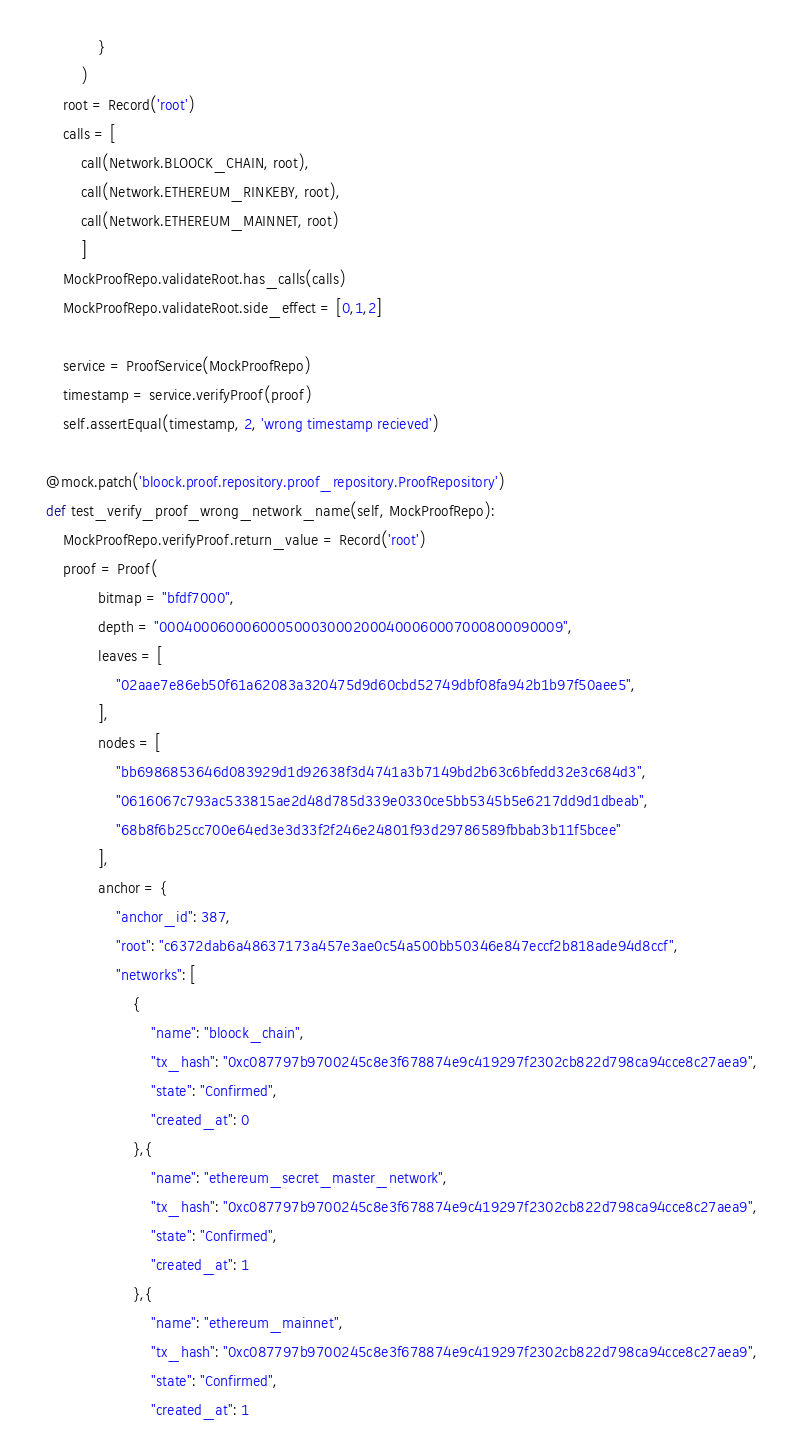Convert code to text. <code><loc_0><loc_0><loc_500><loc_500><_Python_>                }
            )
        root = Record('root')
        calls = [
            call(Network.BLOOCK_CHAIN, root),
            call(Network.ETHEREUM_RINKEBY, root),
            call(Network.ETHEREUM_MAINNET, root)
            ]
        MockProofRepo.validateRoot.has_calls(calls)
        MockProofRepo.validateRoot.side_effect = [0,1,2]

        service = ProofService(MockProofRepo)
        timestamp = service.verifyProof(proof)
        self.assertEqual(timestamp, 2, 'wrong timestamp recieved')

    @mock.patch('bloock.proof.repository.proof_repository.ProofRepository')
    def test_verify_proof_wrong_network_name(self, MockProofRepo):
        MockProofRepo.verifyProof.return_value = Record('root')
        proof = Proof(
                bitmap = "bfdf7000",
                depth = "000400060006000500030002000400060007000800090009",
                leaves = [
                    "02aae7e86eb50f61a62083a320475d9d60cbd52749dbf08fa942b1b97f50aee5",
                ],
                nodes = [
                    "bb6986853646d083929d1d92638f3d4741a3b7149bd2b63c6bfedd32e3c684d3",
                    "0616067c793ac533815ae2d48d785d339e0330ce5bb5345b5e6217dd9d1dbeab",
                    "68b8f6b25cc700e64ed3e3d33f2f246e24801f93d29786589fbbab3b11f5bcee"
                ],
                anchor = {
                    "anchor_id": 387,
                    "root": "c6372dab6a48637173a457e3ae0c54a500bb50346e847eccf2b818ade94d8ccf",
                    "networks": [
                        {
                            "name": "bloock_chain",
                            "tx_hash": "0xc087797b9700245c8e3f678874e9c419297f2302cb822d798ca94cce8c27aea9",
                            "state": "Confirmed",
                            "created_at": 0
                        },{
                            "name": "ethereum_secret_master_network",
                            "tx_hash": "0xc087797b9700245c8e3f678874e9c419297f2302cb822d798ca94cce8c27aea9",
                            "state": "Confirmed",
                            "created_at": 1
                        },{
                            "name": "ethereum_mainnet",
                            "tx_hash": "0xc087797b9700245c8e3f678874e9c419297f2302cb822d798ca94cce8c27aea9",
                            "state": "Confirmed",
                            "created_at": 1</code> 